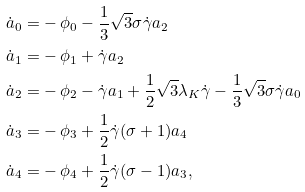Convert formula to latex. <formula><loc_0><loc_0><loc_500><loc_500>\dot { a } _ { 0 } = & - \phi _ { 0 } - { \frac { 1 } { 3 } } { \sqrt { 3 } } { \sigma } \dot { \gamma } a _ { 2 } \\ \dot { a } _ { 1 } = & - \phi _ { 1 } + \dot { \gamma } a _ { 2 } \\ \dot { a } _ { 2 } = & - \phi _ { 2 } - \dot { \gamma } a _ { 1 } + { \frac { 1 } { 2 } } { \sqrt { 3 } } { \lambda } _ { K } \dot { \gamma } - { \frac { 1 } { 3 } } { \sqrt { 3 } } { \sigma } \dot { \gamma } a _ { 0 } \\ \dot { a } _ { 3 } = & - \phi _ { 3 } + { \frac { 1 } { 2 } } \dot { \gamma } ( { \sigma } + 1 ) a _ { 4 } \\ \dot { a } _ { 4 } = & - \phi _ { 4 } + { \frac { 1 } { 2 } } \dot { \gamma } ( { \sigma } - 1 ) a _ { 3 } ,</formula> 